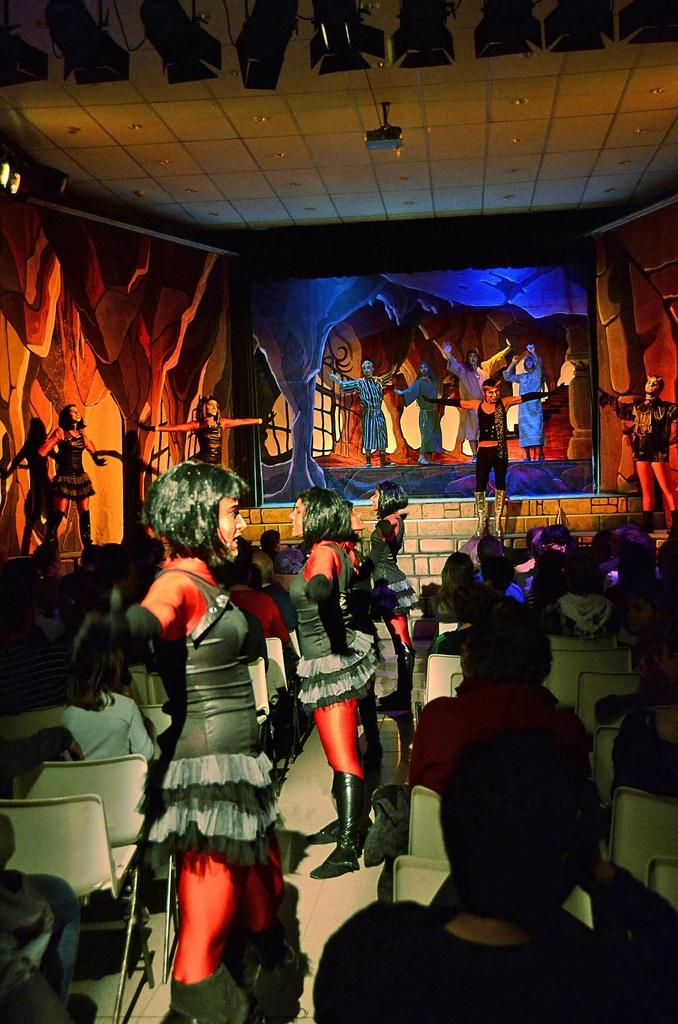How many people are in the image? There are many people in the image. What are the people wearing? The people are wearing clothes. What positions are the people in? Some people are standing, while others are sitting. What type of furniture is in the image? There are chairs in the image. What is the surface beneath the people's feet? The image shows a floor. What is hanging on the wall in the image? There is a poster in the image. What source of illumination is present in the image? There is a light in the image. What type of paper is the manager holding in the image? There is no manager or paper present in the image. 